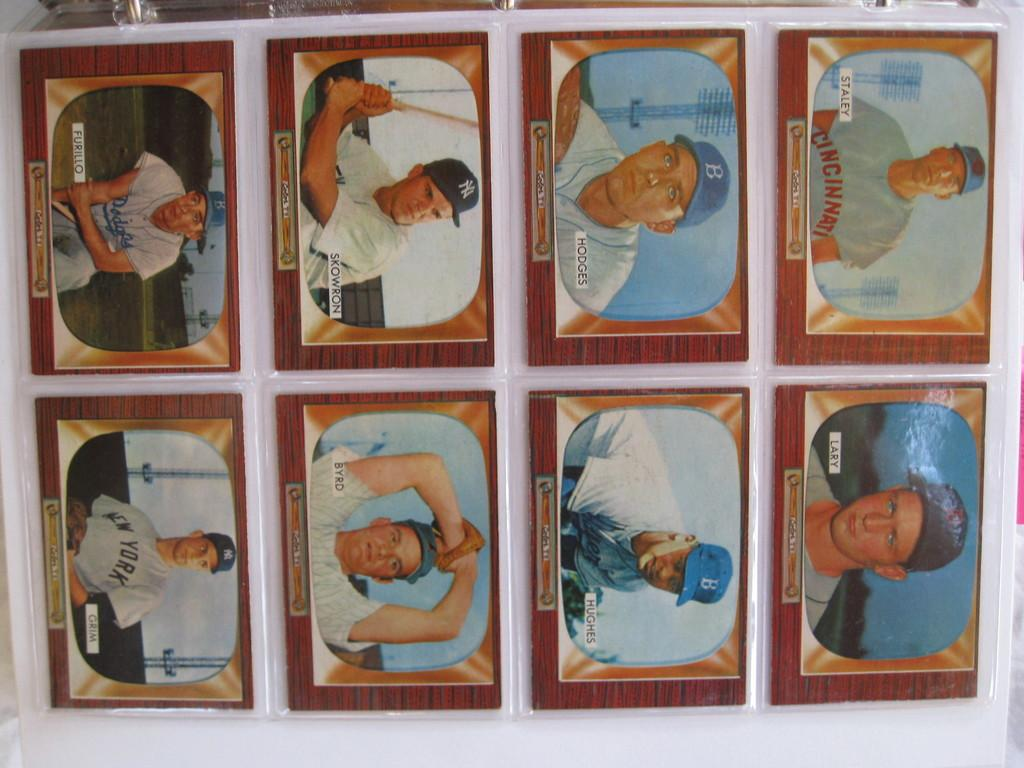What type of items are depicted on the cards in the image? There are cards with covers in the image, and some of them feature humans. What are the humans wearing on their heads in the image? Some humans on the cards are wearing caps. What are the humans holding in their hands on the cards? Some humans on the cards are holding objects. On what surface are the cards placed in the image? The cards are placed on a white surface. How many clams can be seen on the cards in the image? There are no clams present on the cards in the image. What type of glass is being used by the humans on the cards? There is no glass visible in the image; the humans are holding objects other than glass. 